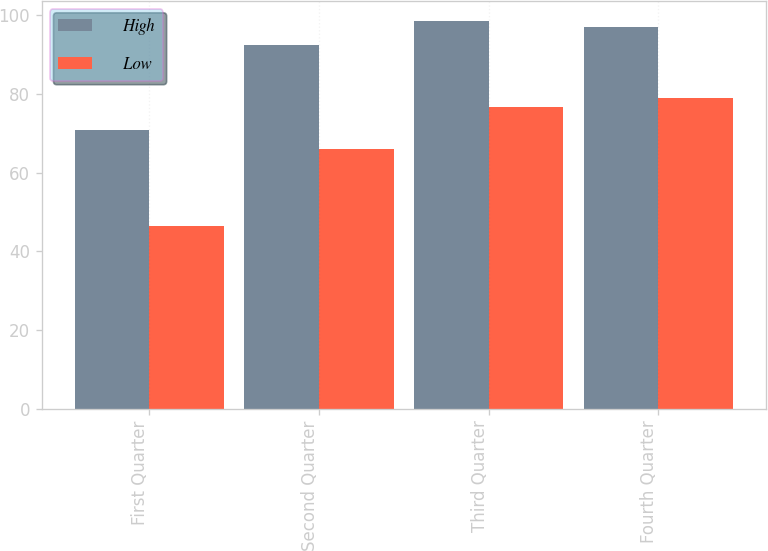<chart> <loc_0><loc_0><loc_500><loc_500><stacked_bar_chart><ecel><fcel>First Quarter<fcel>Second Quarter<fcel>Third Quarter<fcel>Fourth Quarter<nl><fcel>High<fcel>70.75<fcel>92.39<fcel>98.66<fcel>97.11<nl><fcel>Low<fcel>46.46<fcel>66.08<fcel>76.75<fcel>79.02<nl></chart> 